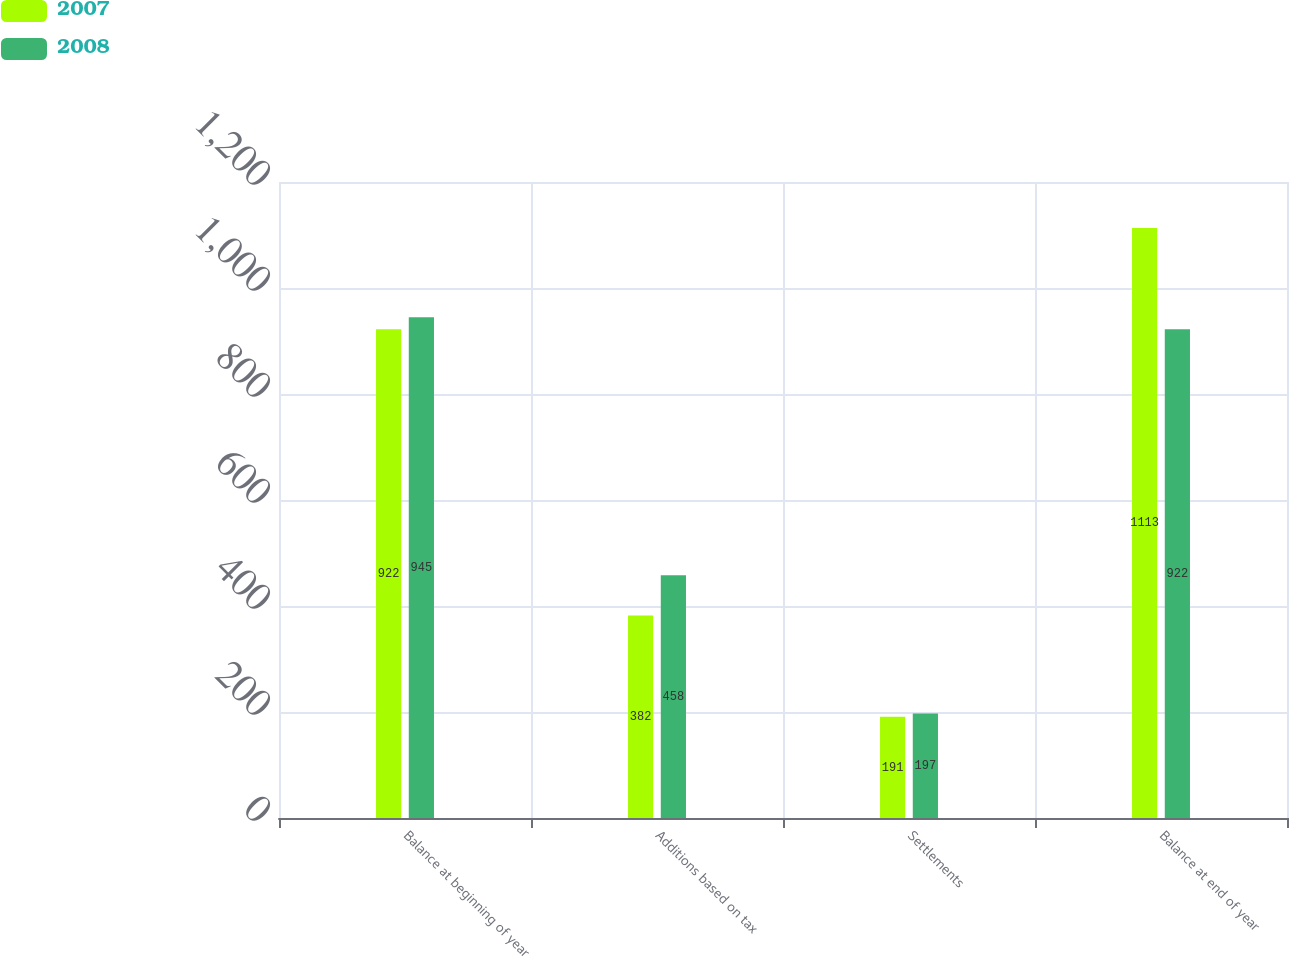Convert chart to OTSL. <chart><loc_0><loc_0><loc_500><loc_500><stacked_bar_chart><ecel><fcel>Balance at beginning of year<fcel>Additions based on tax<fcel>Settlements<fcel>Balance at end of year<nl><fcel>2007<fcel>922<fcel>382<fcel>191<fcel>1113<nl><fcel>2008<fcel>945<fcel>458<fcel>197<fcel>922<nl></chart> 